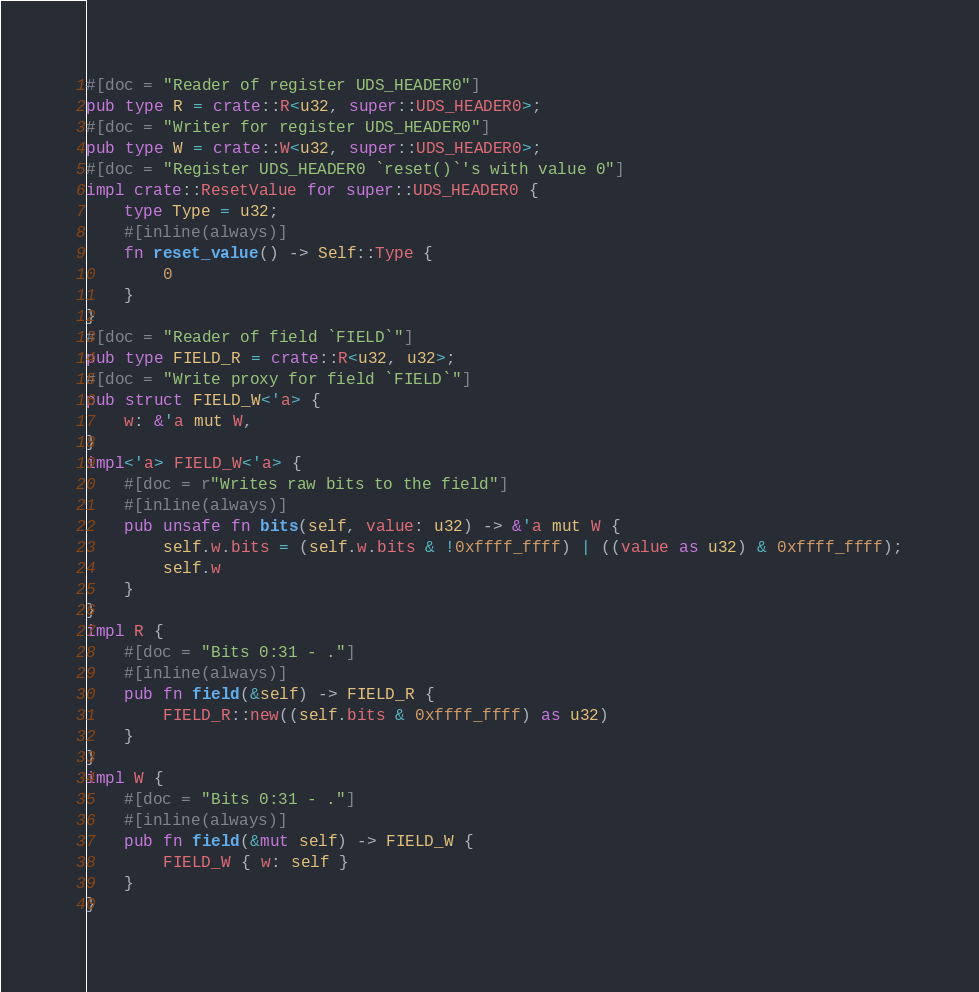<code> <loc_0><loc_0><loc_500><loc_500><_Rust_>#[doc = "Reader of register UDS_HEADER0"]
pub type R = crate::R<u32, super::UDS_HEADER0>;
#[doc = "Writer for register UDS_HEADER0"]
pub type W = crate::W<u32, super::UDS_HEADER0>;
#[doc = "Register UDS_HEADER0 `reset()`'s with value 0"]
impl crate::ResetValue for super::UDS_HEADER0 {
    type Type = u32;
    #[inline(always)]
    fn reset_value() -> Self::Type {
        0
    }
}
#[doc = "Reader of field `FIELD`"]
pub type FIELD_R = crate::R<u32, u32>;
#[doc = "Write proxy for field `FIELD`"]
pub struct FIELD_W<'a> {
    w: &'a mut W,
}
impl<'a> FIELD_W<'a> {
    #[doc = r"Writes raw bits to the field"]
    #[inline(always)]
    pub unsafe fn bits(self, value: u32) -> &'a mut W {
        self.w.bits = (self.w.bits & !0xffff_ffff) | ((value as u32) & 0xffff_ffff);
        self.w
    }
}
impl R {
    #[doc = "Bits 0:31 - ."]
    #[inline(always)]
    pub fn field(&self) -> FIELD_R {
        FIELD_R::new((self.bits & 0xffff_ffff) as u32)
    }
}
impl W {
    #[doc = "Bits 0:31 - ."]
    #[inline(always)]
    pub fn field(&mut self) -> FIELD_W {
        FIELD_W { w: self }
    }
}
</code> 